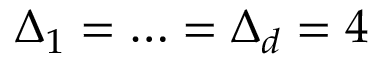<formula> <loc_0><loc_0><loc_500><loc_500>\Delta _ { 1 } = \dots = \Delta _ { d } = 4</formula> 